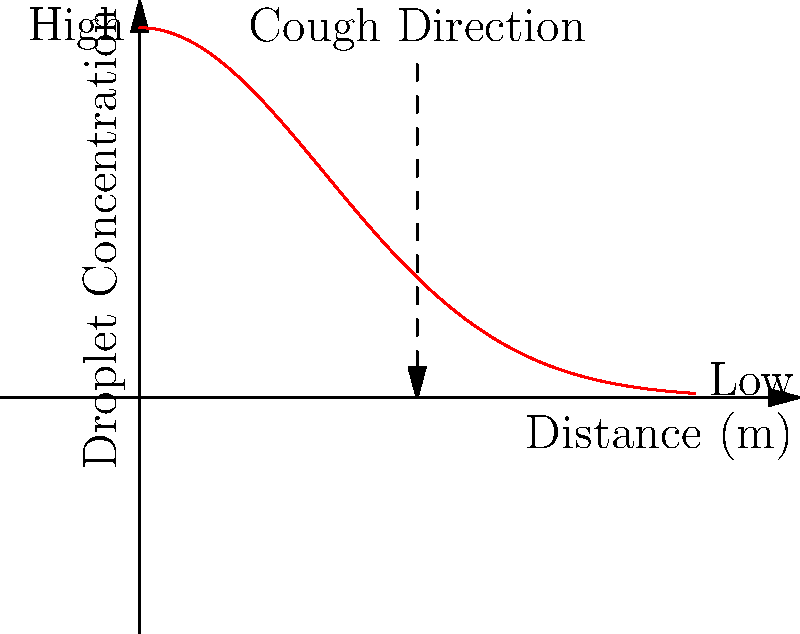Based on the graph showing the concentration of droplets expelled during a cough, what can be inferred about the mechanics of coughing and its potential for spreading tuberculosis? How might this information influence precautionary measures? 1. Graph interpretation: The graph shows droplet concentration decreasing exponentially with distance from the source of the cough.

2. Mechanics of coughing: When a person coughs, they expel droplets containing moisture and potentially infectious particles.

3. Droplet distribution: The highest concentration of droplets is near the source (x = 0), rapidly decreasing as distance increases.

4. Exponential decay: The curve follows an exponential decay function, approximated by $f(x) = 2e^{-x^2/2}$, where x is the distance from the source.

5. Transmission risk: The risk of transmission is highest in close proximity to the infected person and decreases with distance.

6. Airflow patterns: The graph indirectly represents airflow patterns, showing how droplets disperse in the air.

7. Precautionary measures: This information suggests maintaining a safe distance (social distancing) and using face masks to reduce droplet spread.

8. Ventilation importance: Good ventilation can help disperse droplets more quickly, reducing concentration in enclosed spaces.

9. Tuberculosis spread: For tuberculosis, which is airborne, this graph emphasizes the importance of proper isolation and air filtration in healthcare settings.
Answer: Coughing expels droplets in an exponentially decreasing concentration pattern, with highest risk close to the source, emphasizing the importance of distance, masks, and ventilation in preventing tuberculosis transmission. 